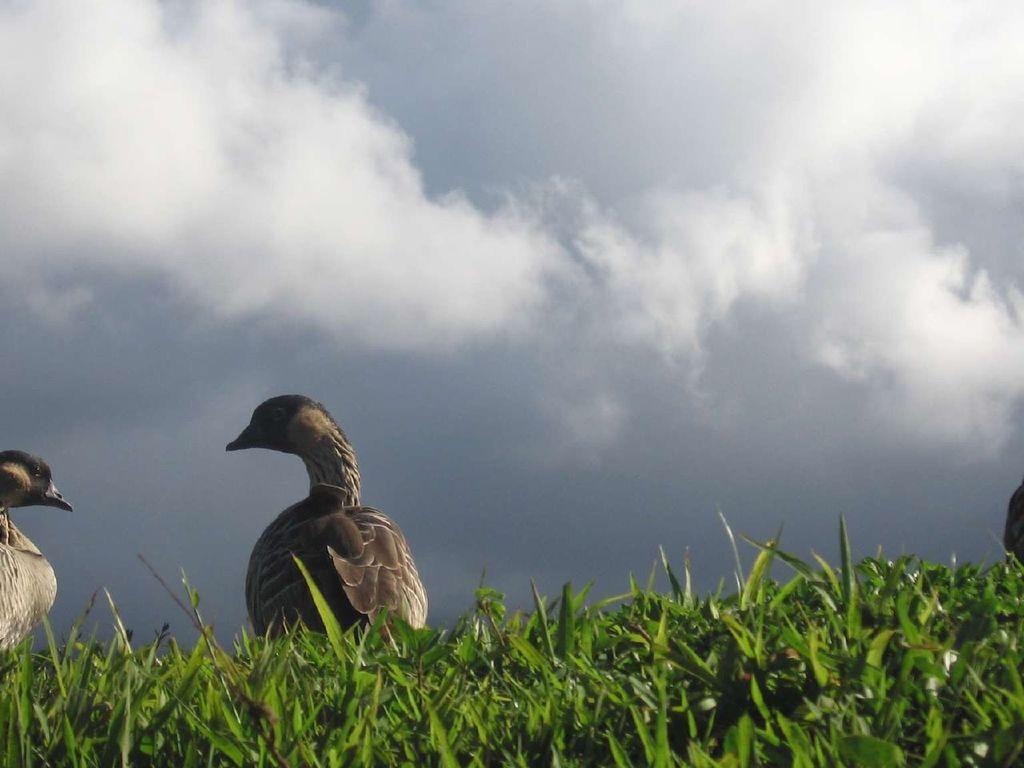Could you give a brief overview of what you see in this image? In this image I can see grass and two birds in the front. In the background I can see clouds and the sky. I can also see a black colour thing on the right side of the image. 